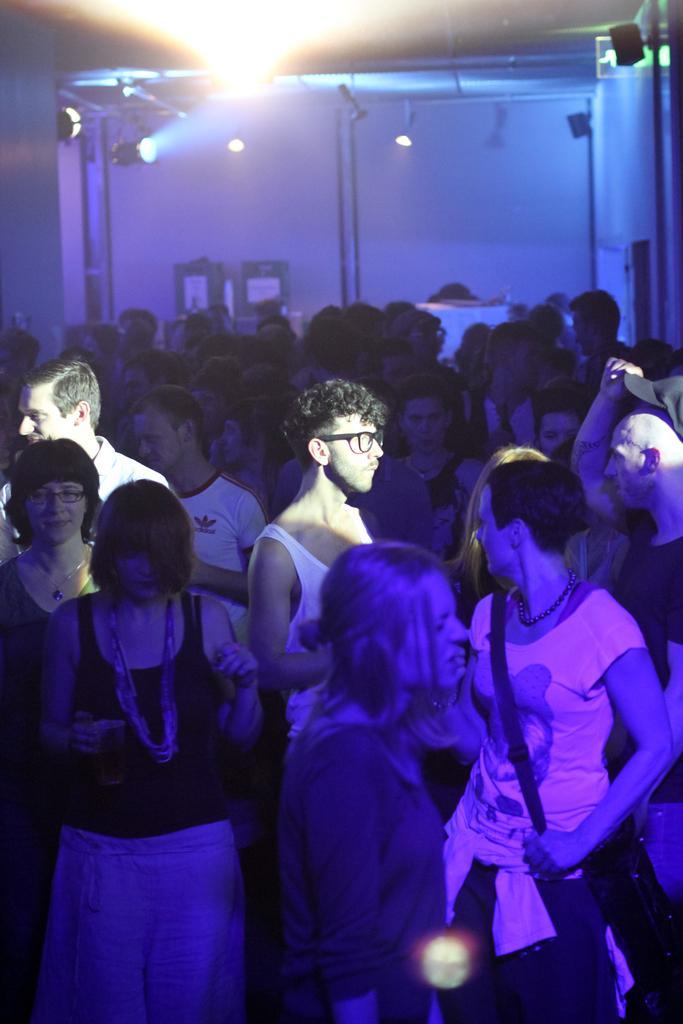In one or two sentences, can you explain what this image depicts? In this picture there are people. In the background of the image we can see wall, focusing lights and objects. 